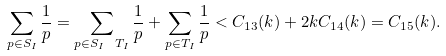<formula> <loc_0><loc_0><loc_500><loc_500>\sum _ { p \in S _ { I } } \frac { 1 } { p } = \sum _ { p \in S _ { I } \ T _ { I } } \frac { 1 } { p } + \sum _ { p \in T _ { I } } \frac { 1 } { p } < C _ { 1 3 } ( k ) + 2 k C _ { 1 4 } ( k ) = C _ { 1 5 } ( k ) .</formula> 